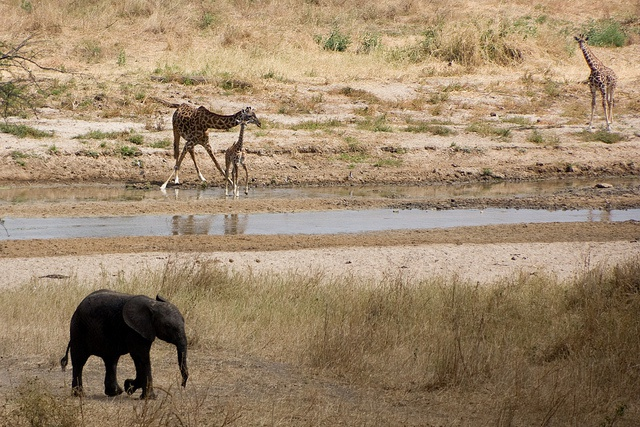Describe the objects in this image and their specific colors. I can see elephant in tan, black, and gray tones, giraffe in tan, black, maroon, and gray tones, giraffe in tan, gray, and brown tones, giraffe in tan, gray, and maroon tones, and giraffe in tan, maroon, gray, black, and brown tones in this image. 